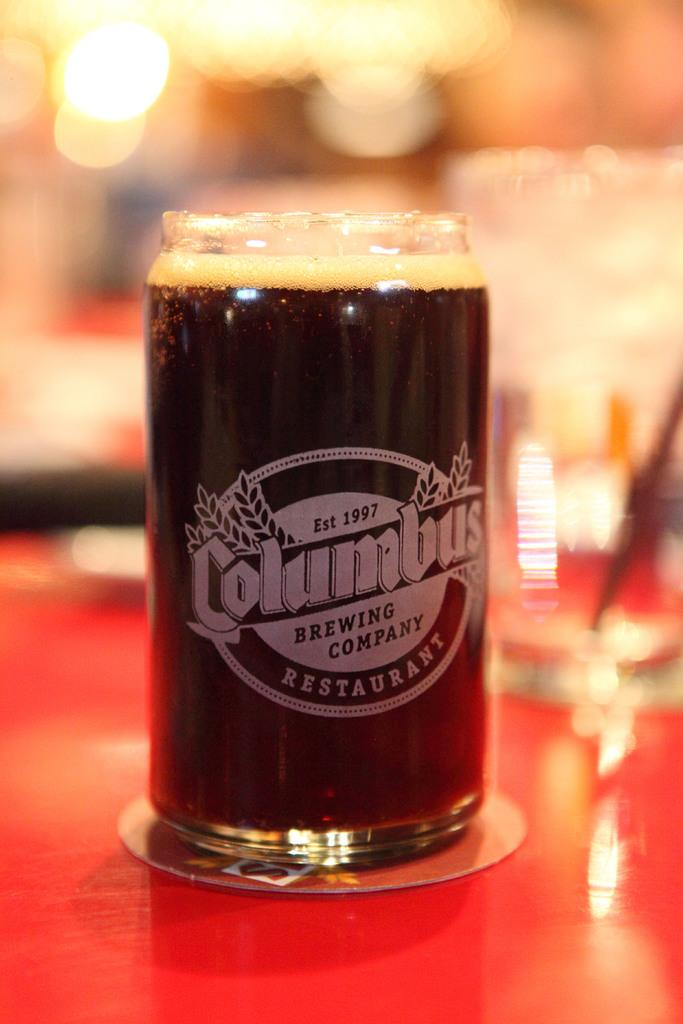Provide a one-sentence caption for the provided image. A glass of beer fizzes in a glass labeled  Columbus Brewing Company. 